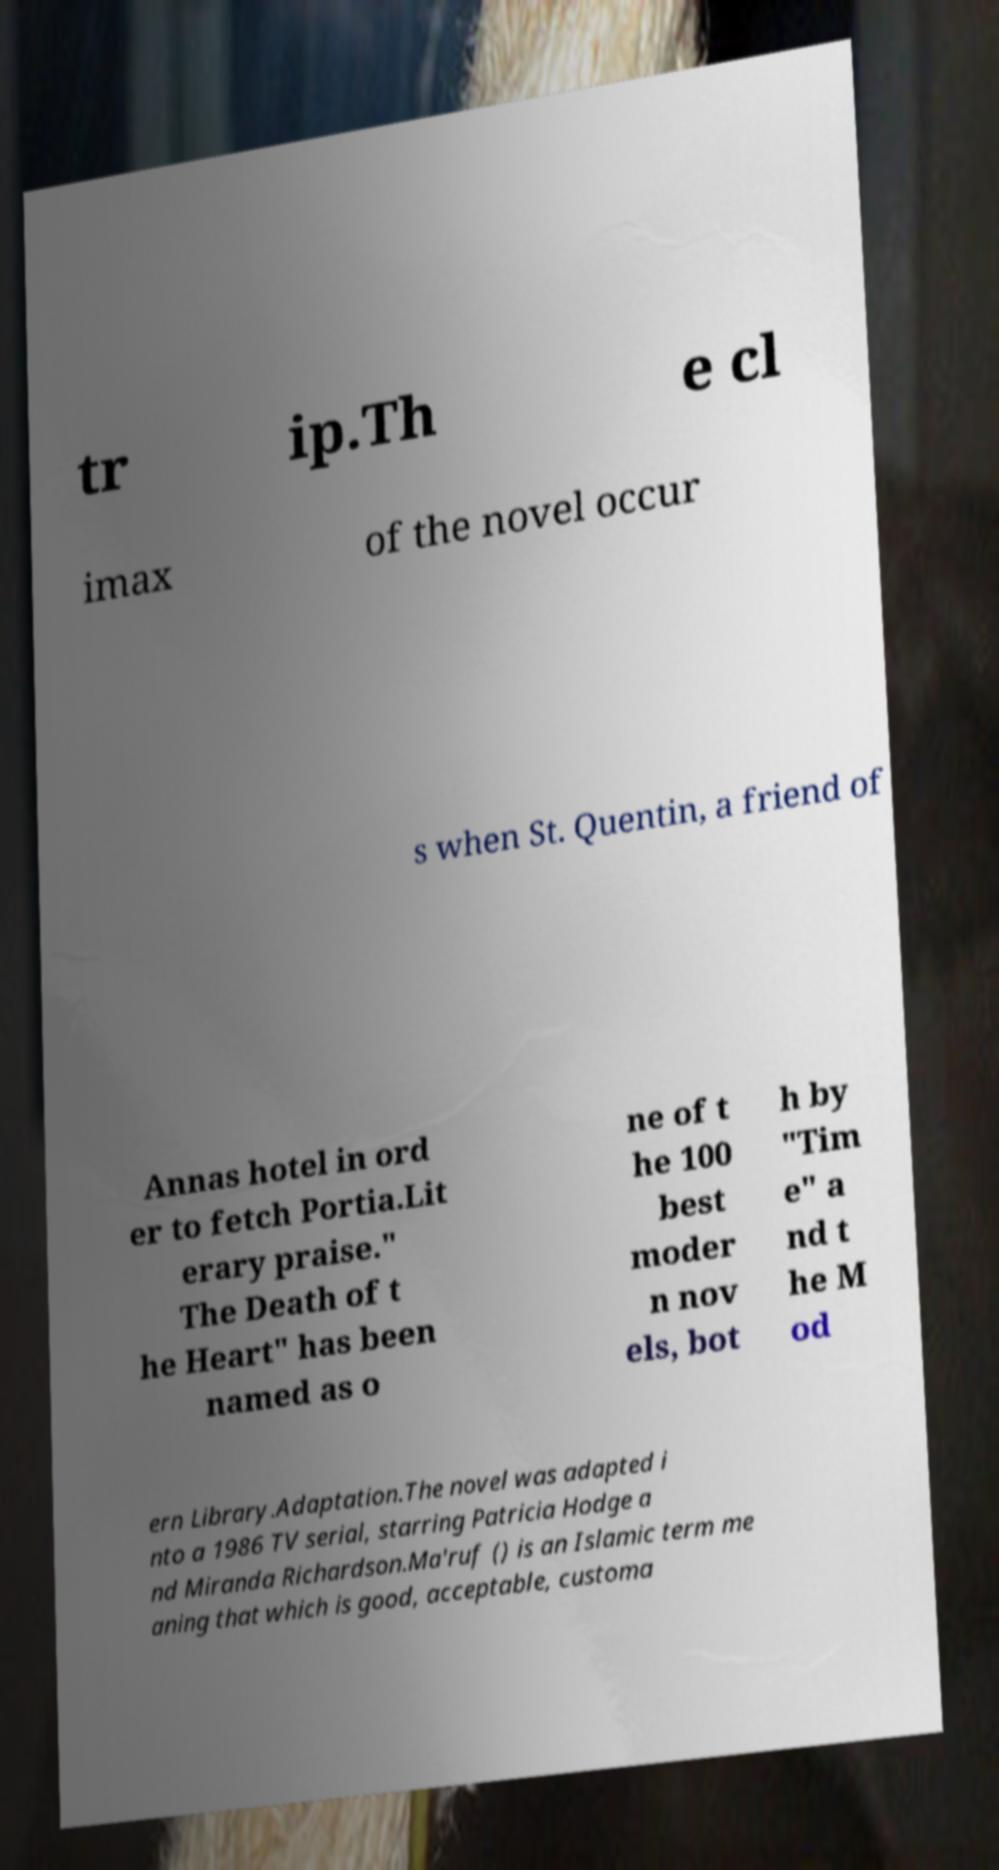There's text embedded in this image that I need extracted. Can you transcribe it verbatim? tr ip.Th e cl imax of the novel occur s when St. Quentin, a friend of Annas hotel in ord er to fetch Portia.Lit erary praise." The Death of t he Heart" has been named as o ne of t he 100 best moder n nov els, bot h by "Tim e" a nd t he M od ern Library.Adaptation.The novel was adapted i nto a 1986 TV serial, starring Patricia Hodge a nd Miranda Richardson.Ma'ruf () is an Islamic term me aning that which is good, acceptable, customa 